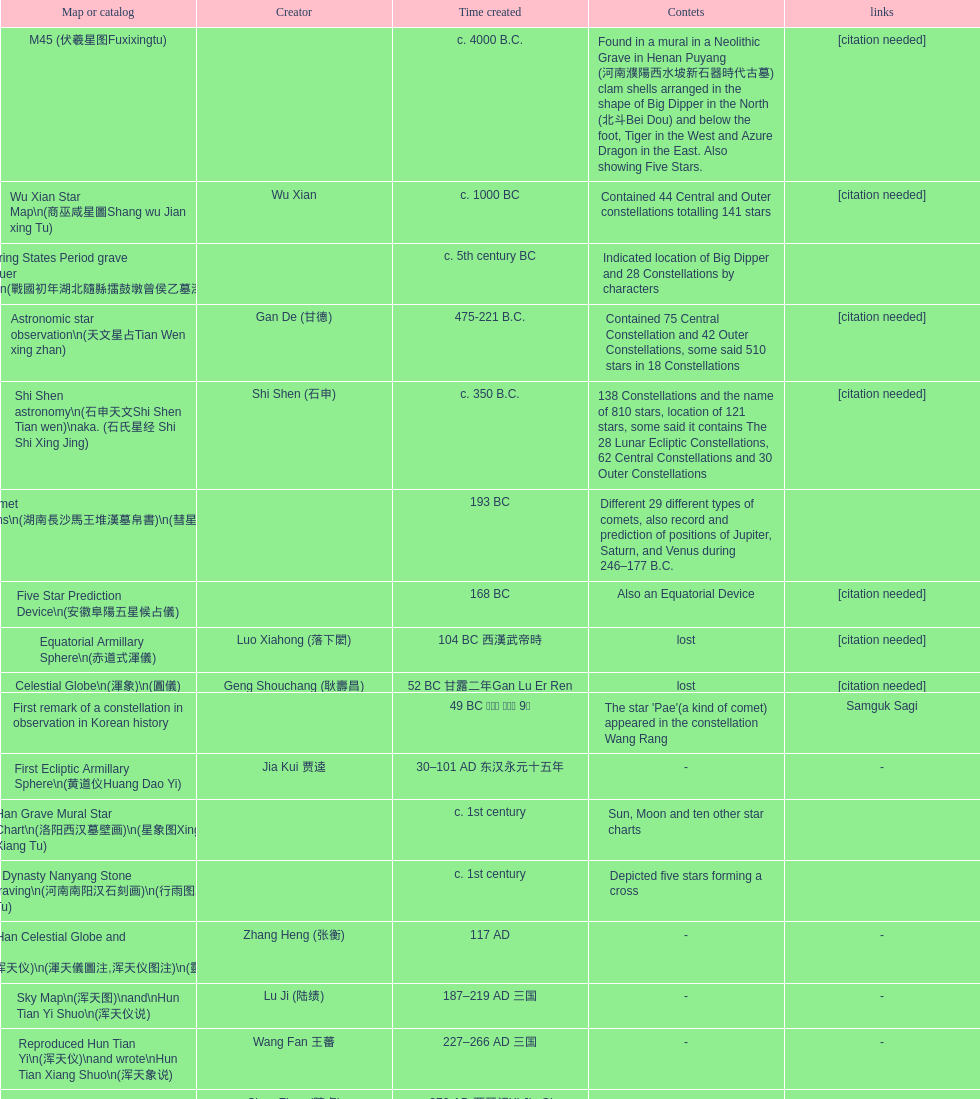What is the distinction between the date of creation for the five star prediction device and the date of creation for the han comet diagrams? 25 years. 